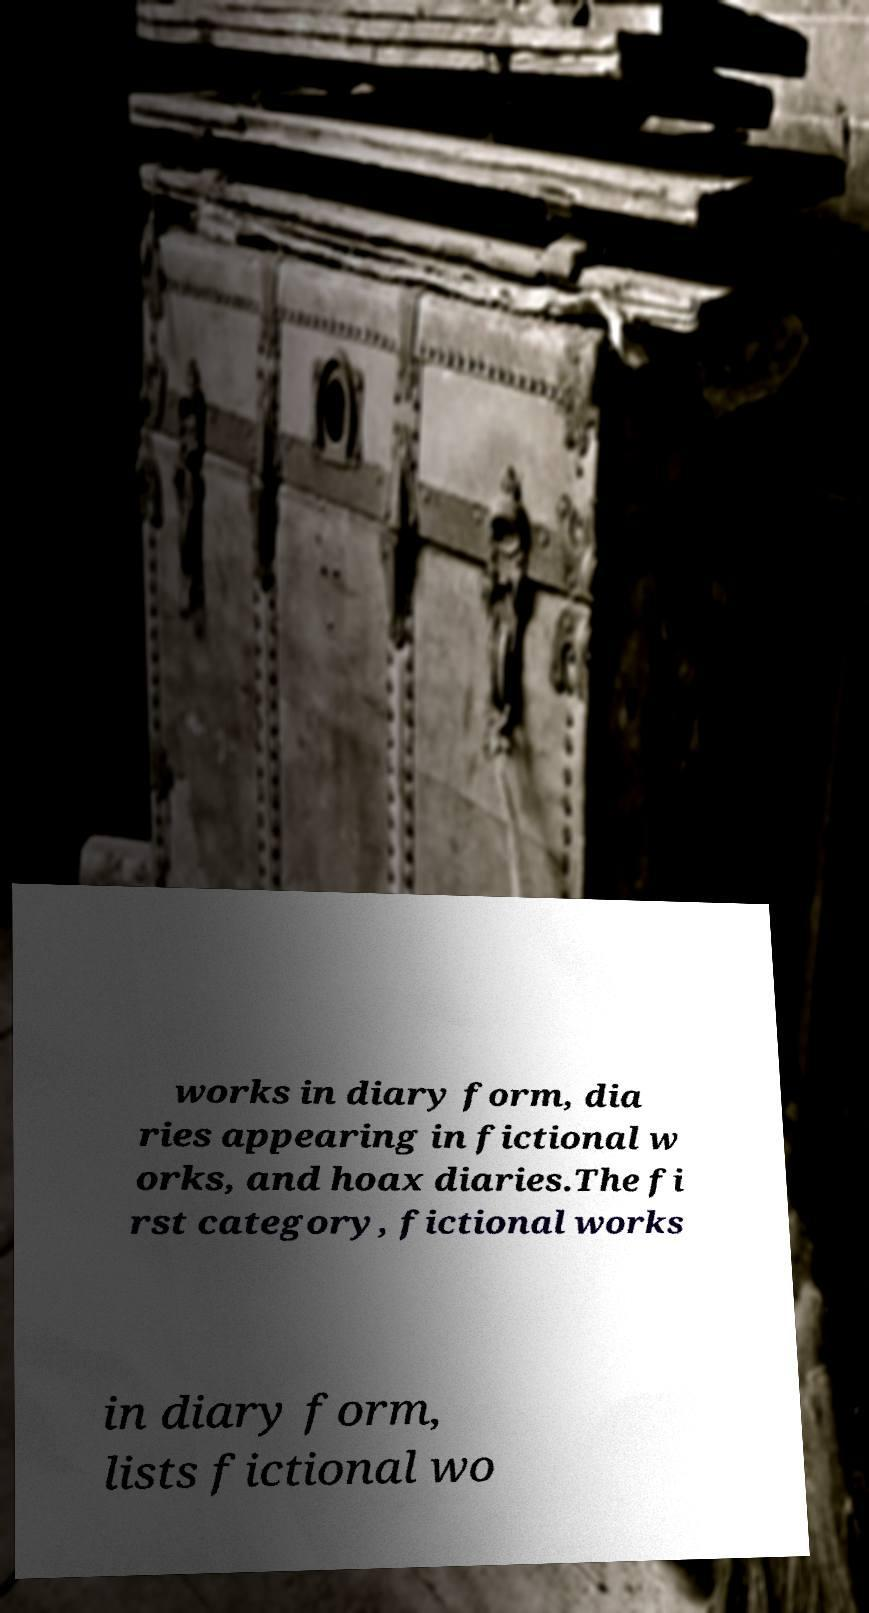What messages or text are displayed in this image? I need them in a readable, typed format. works in diary form, dia ries appearing in fictional w orks, and hoax diaries.The fi rst category, fictional works in diary form, lists fictional wo 